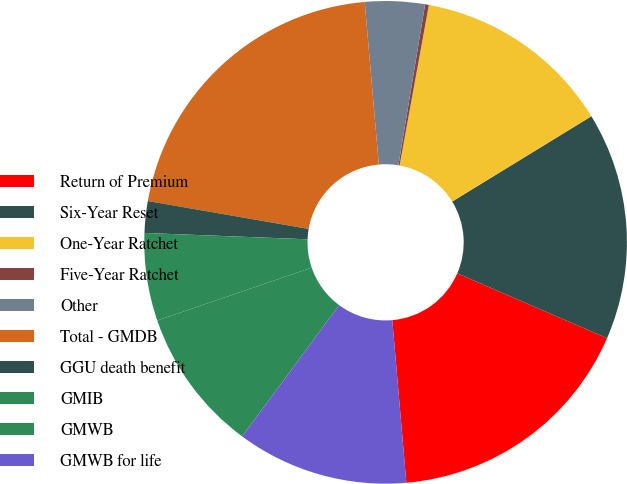Convert chart. <chart><loc_0><loc_0><loc_500><loc_500><pie_chart><fcel>Return of Premium<fcel>Six-Year Reset<fcel>One-Year Ratchet<fcel>Five-Year Ratchet<fcel>Other<fcel>Total - GMDB<fcel>GGU death benefit<fcel>GMIB<fcel>GMWB<fcel>GMWB for life<nl><fcel>17.13%<fcel>15.25%<fcel>13.38%<fcel>0.25%<fcel>4.0%<fcel>20.88%<fcel>2.12%<fcel>5.87%<fcel>9.62%<fcel>11.5%<nl></chart> 